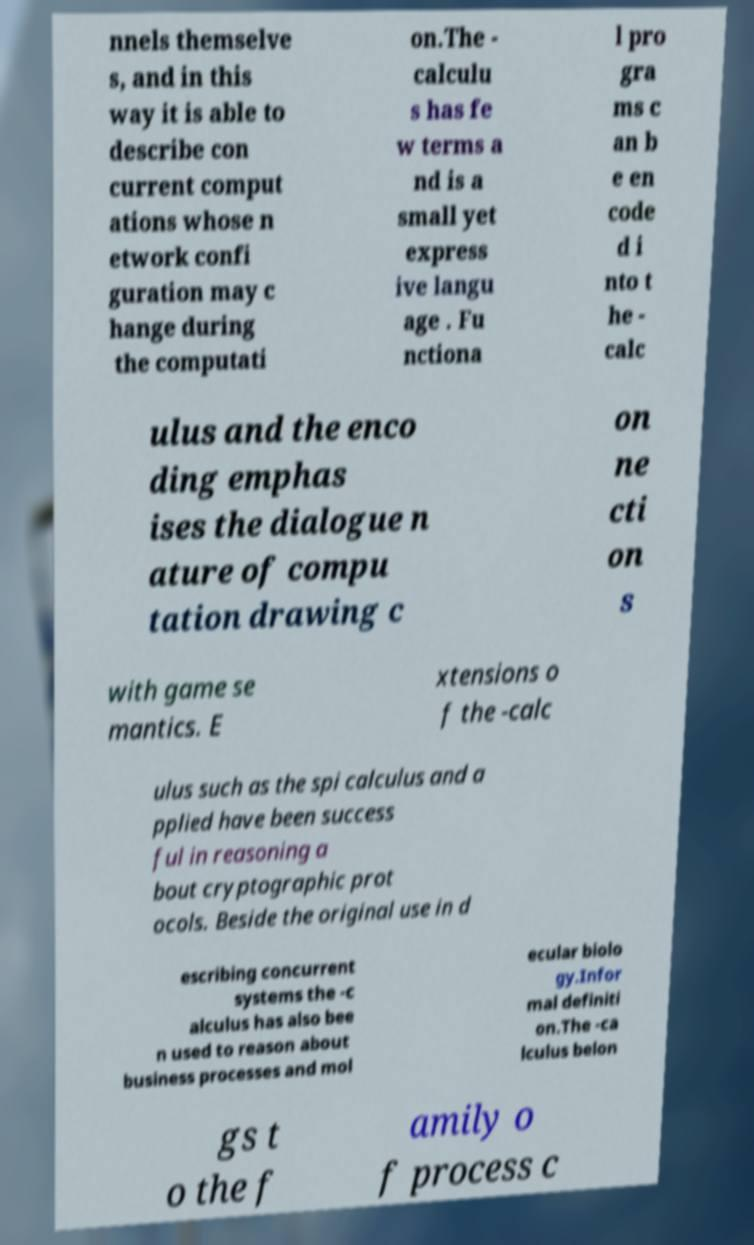I need the written content from this picture converted into text. Can you do that? nnels themselve s, and in this way it is able to describe con current comput ations whose n etwork confi guration may c hange during the computati on.The - calculu s has fe w terms a nd is a small yet express ive langu age . Fu nctiona l pro gra ms c an b e en code d i nto t he - calc ulus and the enco ding emphas ises the dialogue n ature of compu tation drawing c on ne cti on s with game se mantics. E xtensions o f the -calc ulus such as the spi calculus and a pplied have been success ful in reasoning a bout cryptographic prot ocols. Beside the original use in d escribing concurrent systems the -c alculus has also bee n used to reason about business processes and mol ecular biolo gy.Infor mal definiti on.The -ca lculus belon gs t o the f amily o f process c 